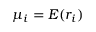<formula> <loc_0><loc_0><loc_500><loc_500>{ \mu _ { i } } = E ( r _ { i } )</formula> 